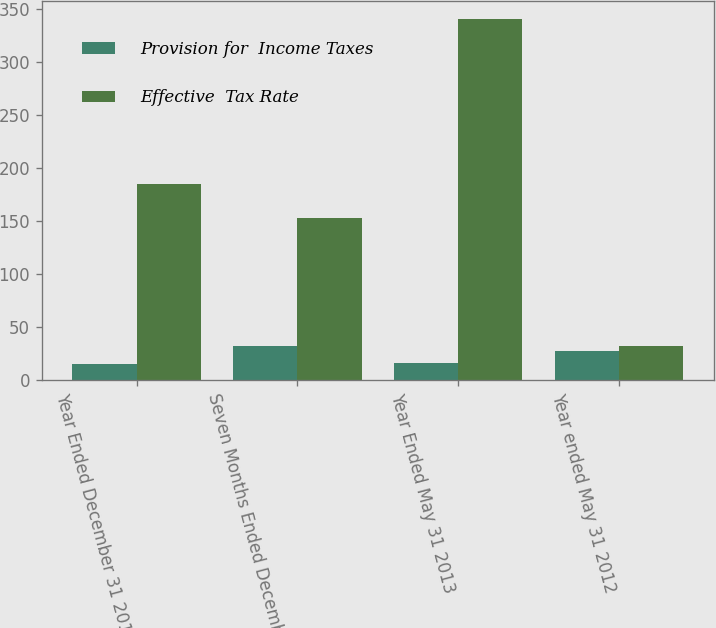<chart> <loc_0><loc_0><loc_500><loc_500><stacked_bar_chart><ecel><fcel>Year Ended December 31 2014<fcel>Seven Months Ended December 31<fcel>Year Ended May 31 2013<fcel>Year ended May 31 2012<nl><fcel>Provision for  Income Taxes<fcel>15.2<fcel>31.5<fcel>15.4<fcel>27.1<nl><fcel>Effective  Tax Rate<fcel>184.7<fcel>152.6<fcel>341<fcel>31.5<nl></chart> 